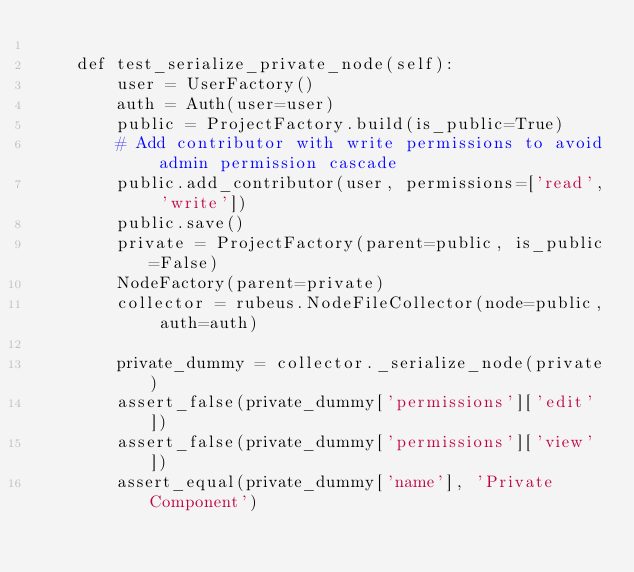Convert code to text. <code><loc_0><loc_0><loc_500><loc_500><_Python_>
    def test_serialize_private_node(self):
        user = UserFactory()
        auth = Auth(user=user)
        public = ProjectFactory.build(is_public=True)
        # Add contributor with write permissions to avoid admin permission cascade
        public.add_contributor(user, permissions=['read', 'write'])
        public.save()
        private = ProjectFactory(parent=public, is_public=False)
        NodeFactory(parent=private)
        collector = rubeus.NodeFileCollector(node=public, auth=auth)

        private_dummy = collector._serialize_node(private)
        assert_false(private_dummy['permissions']['edit'])
        assert_false(private_dummy['permissions']['view'])
        assert_equal(private_dummy['name'], 'Private Component')</code> 